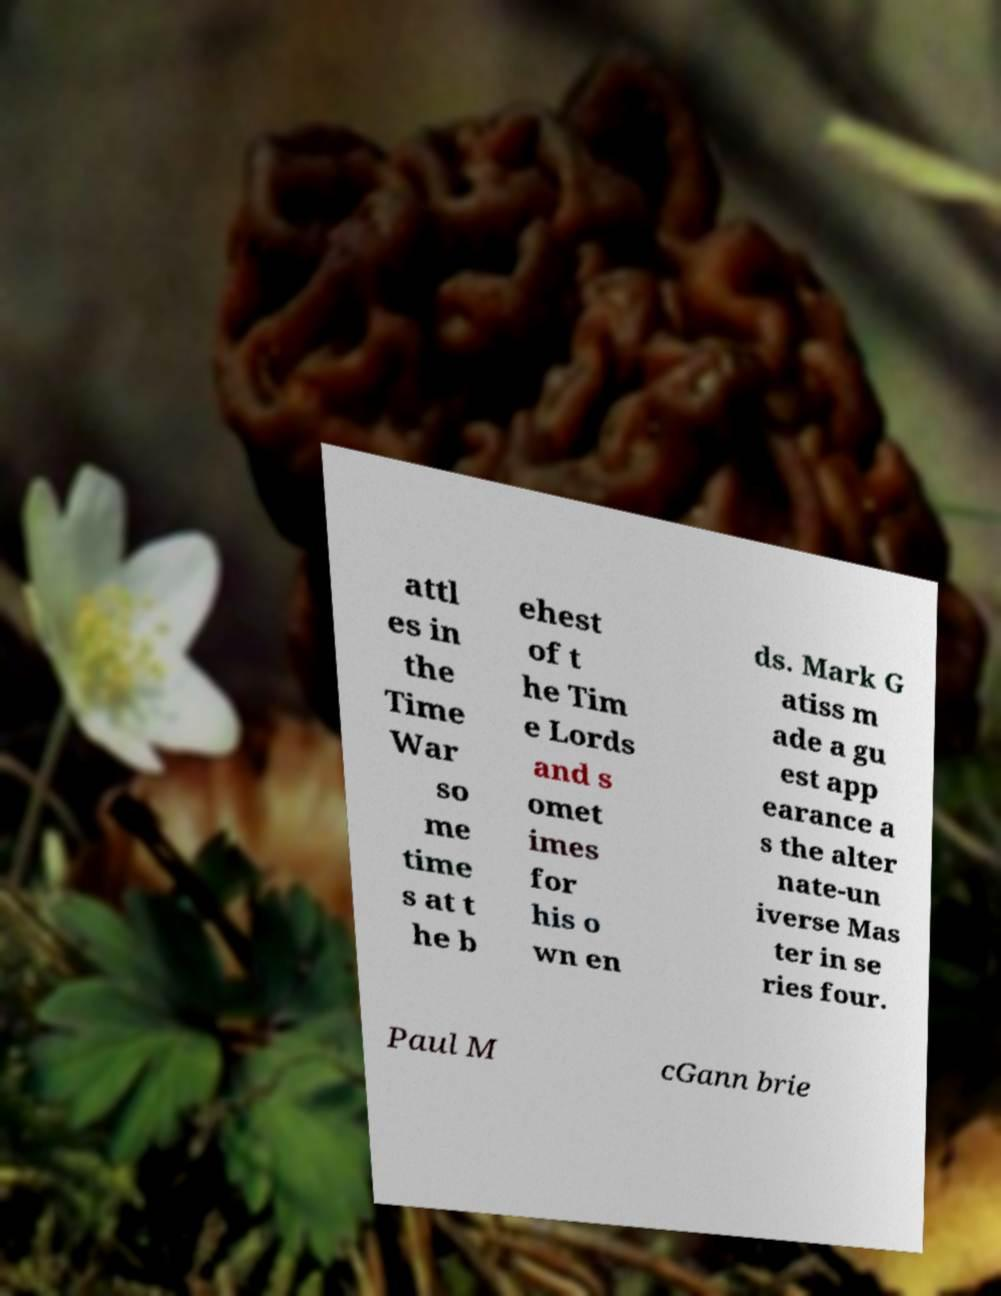Please identify and transcribe the text found in this image. attl es in the Time War so me time s at t he b ehest of t he Tim e Lords and s omet imes for his o wn en ds. Mark G atiss m ade a gu est app earance a s the alter nate-un iverse Mas ter in se ries four. Paul M cGann brie 